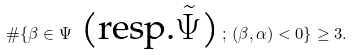<formula> <loc_0><loc_0><loc_500><loc_500>\# \{ \beta \in \Psi \text { (resp.$\tilde{\Psi}$)} \, ; \, ( \beta , \alpha ) < 0 \} \geq 3 .</formula> 